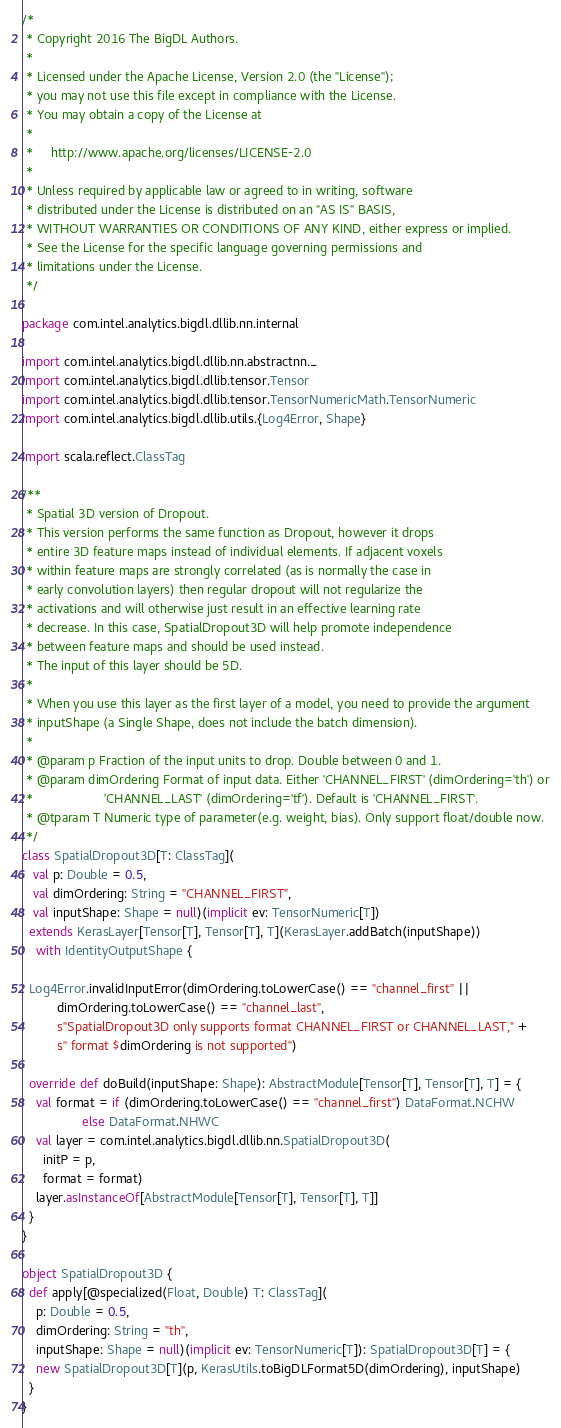<code> <loc_0><loc_0><loc_500><loc_500><_Scala_>/*
 * Copyright 2016 The BigDL Authors.
 *
 * Licensed under the Apache License, Version 2.0 (the "License");
 * you may not use this file except in compliance with the License.
 * You may obtain a copy of the License at
 *
 *     http://www.apache.org/licenses/LICENSE-2.0
 *
 * Unless required by applicable law or agreed to in writing, software
 * distributed under the License is distributed on an "AS IS" BASIS,
 * WITHOUT WARRANTIES OR CONDITIONS OF ANY KIND, either express or implied.
 * See the License for the specific language governing permissions and
 * limitations under the License.
 */

package com.intel.analytics.bigdl.dllib.nn.internal

import com.intel.analytics.bigdl.dllib.nn.abstractnn._
import com.intel.analytics.bigdl.dllib.tensor.Tensor
import com.intel.analytics.bigdl.dllib.tensor.TensorNumericMath.TensorNumeric
import com.intel.analytics.bigdl.dllib.utils.{Log4Error, Shape}

import scala.reflect.ClassTag

/**
 * Spatial 3D version of Dropout.
 * This version performs the same function as Dropout, however it drops
 * entire 3D feature maps instead of individual elements. If adjacent voxels
 * within feature maps are strongly correlated (as is normally the case in
 * early convolution layers) then regular dropout will not regularize the
 * activations and will otherwise just result in an effective learning rate
 * decrease. In this case, SpatialDropout3D will help promote independence
 * between feature maps and should be used instead.
 * The input of this layer should be 5D.
 *
 * When you use this layer as the first layer of a model, you need to provide the argument
 * inputShape (a Single Shape, does not include the batch dimension).
 *
 * @param p Fraction of the input units to drop. Double between 0 and 1.
 * @param dimOrdering Format of input data. Either 'CHANNEL_FIRST' (dimOrdering='th') or
 *                    'CHANNEL_LAST' (dimOrdering='tf'). Default is 'CHANNEL_FIRST'.
 * @tparam T Numeric type of parameter(e.g. weight, bias). Only support float/double now.
 */
class SpatialDropout3D[T: ClassTag](
   val p: Double = 0.5,
   val dimOrdering: String = "CHANNEL_FIRST",
   val inputShape: Shape = null)(implicit ev: TensorNumeric[T])
  extends KerasLayer[Tensor[T], Tensor[T], T](KerasLayer.addBatch(inputShape))
    with IdentityOutputShape {

  Log4Error.invalidInputError(dimOrdering.toLowerCase() == "channel_first" ||
          dimOrdering.toLowerCase() == "channel_last",
          s"SpatialDropout3D only supports format CHANNEL_FIRST or CHANNEL_LAST," +
          s" format $dimOrdering is not supported")

  override def doBuild(inputShape: Shape): AbstractModule[Tensor[T], Tensor[T], T] = {
    val format = if (dimOrdering.toLowerCase() == "channel_first") DataFormat.NCHW
                 else DataFormat.NHWC
    val layer = com.intel.analytics.bigdl.dllib.nn.SpatialDropout3D(
      initP = p,
      format = format)
    layer.asInstanceOf[AbstractModule[Tensor[T], Tensor[T], T]]
  }
}

object SpatialDropout3D {
  def apply[@specialized(Float, Double) T: ClassTag](
    p: Double = 0.5,
    dimOrdering: String = "th",
    inputShape: Shape = null)(implicit ev: TensorNumeric[T]): SpatialDropout3D[T] = {
    new SpatialDropout3D[T](p, KerasUtils.toBigDLFormat5D(dimOrdering), inputShape)
  }
}
</code> 